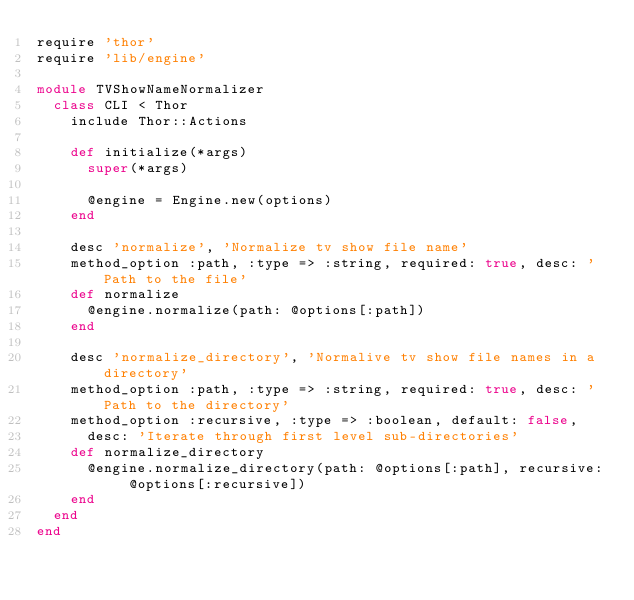<code> <loc_0><loc_0><loc_500><loc_500><_Ruby_>require 'thor'
require 'lib/engine'

module TVShowNameNormalizer
  class CLI < Thor
    include Thor::Actions

    def initialize(*args)
      super(*args)

      @engine = Engine.new(options)
    end

    desc 'normalize', 'Normalize tv show file name'
    method_option :path, :type => :string, required: true, desc: 'Path to the file'
    def normalize
      @engine.normalize(path: @options[:path])
    end

    desc 'normalize_directory', 'Normalive tv show file names in a directory'
    method_option :path, :type => :string, required: true, desc: 'Path to the directory'
    method_option :recursive, :type => :boolean, default: false,
      desc: 'Iterate through first level sub-directories'
    def normalize_directory
      @engine.normalize_directory(path: @options[:path], recursive: @options[:recursive])
    end
  end
end
</code> 